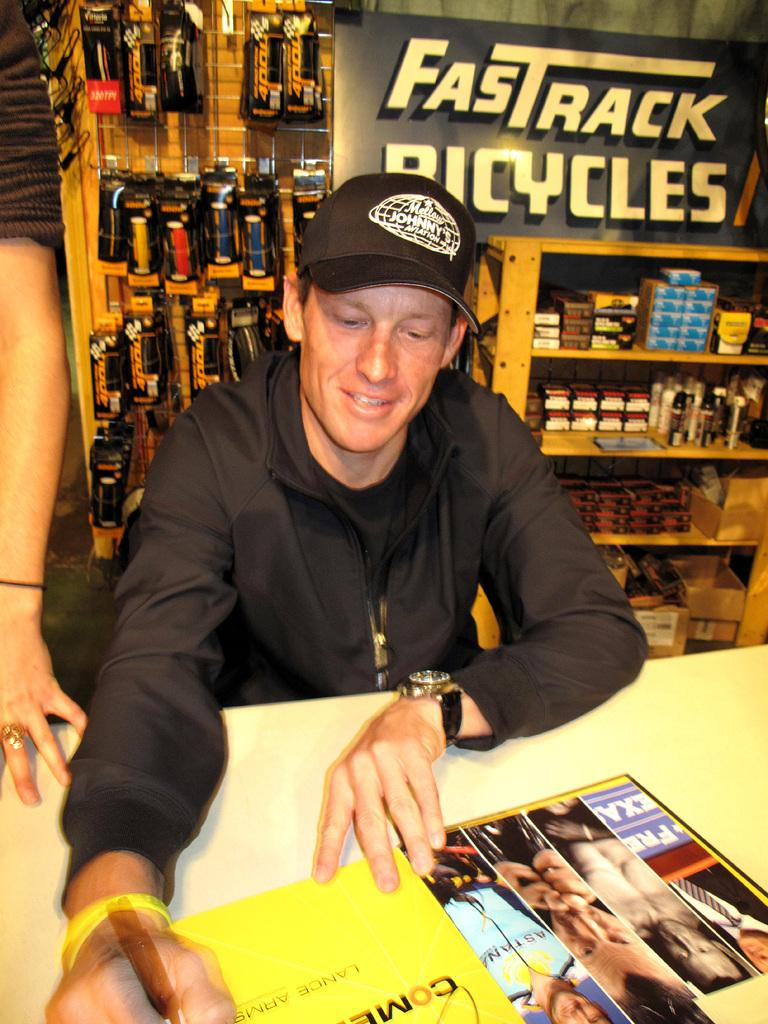<image>
Give a short and clear explanation of the subsequent image. A young man in the Fastrack Bicycles store looks at some photos as he pages through a magazine. 